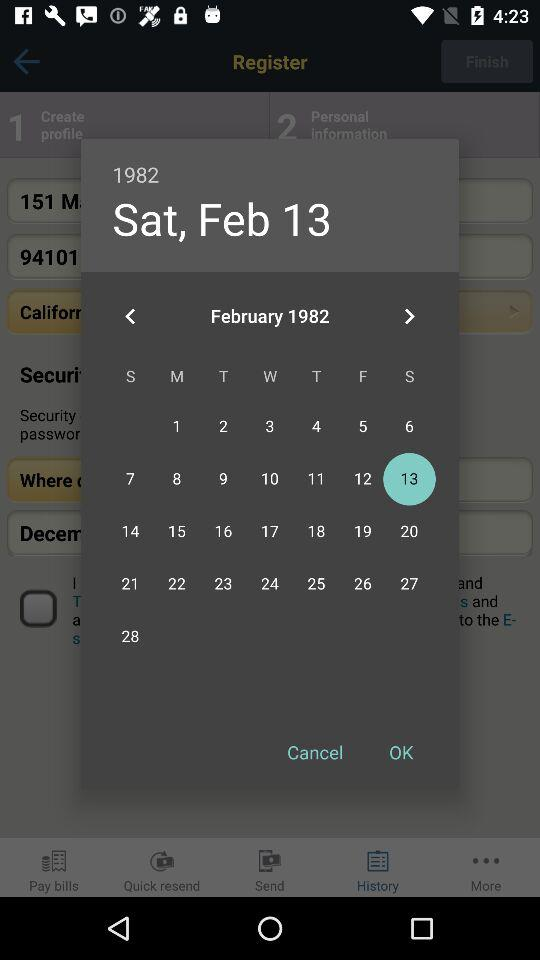What is the selected day? The selected day is Saturday. 